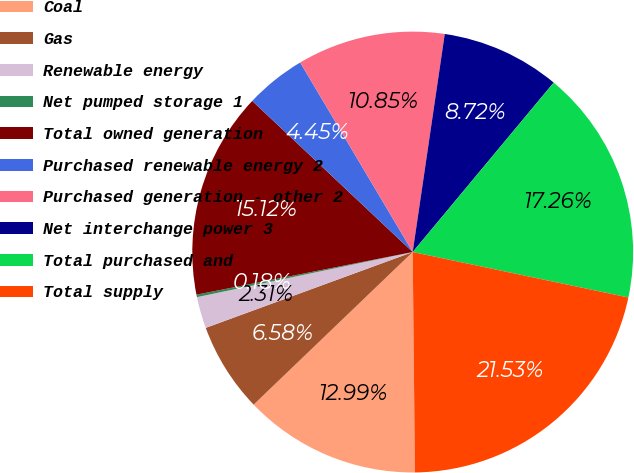Convert chart to OTSL. <chart><loc_0><loc_0><loc_500><loc_500><pie_chart><fcel>Coal<fcel>Gas<fcel>Renewable energy<fcel>Net pumped storage 1<fcel>Total owned generation<fcel>Purchased renewable energy 2<fcel>Purchased generation - other 2<fcel>Net interchange power 3<fcel>Total purchased and<fcel>Total supply<nl><fcel>12.99%<fcel>6.58%<fcel>2.31%<fcel>0.18%<fcel>15.12%<fcel>4.45%<fcel>10.85%<fcel>8.72%<fcel>17.26%<fcel>21.53%<nl></chart> 